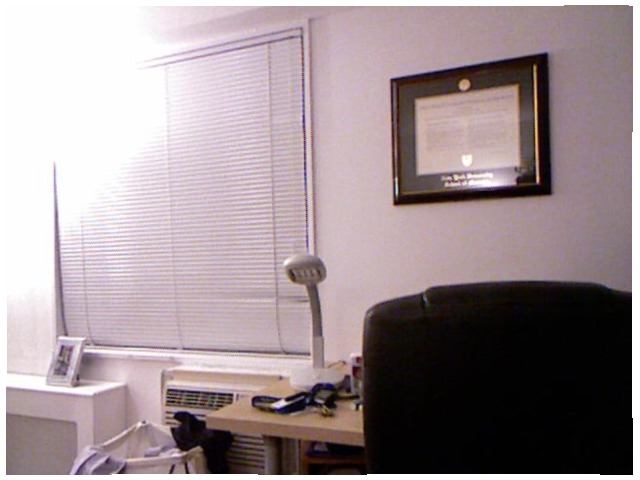<image>
Can you confirm if the chair is under the photo frame? Yes. The chair is positioned underneath the photo frame, with the photo frame above it in the vertical space. Where is the window in relation to the table lamp? Is it on the table lamp? No. The window is not positioned on the table lamp. They may be near each other, but the window is not supported by or resting on top of the table lamp. 